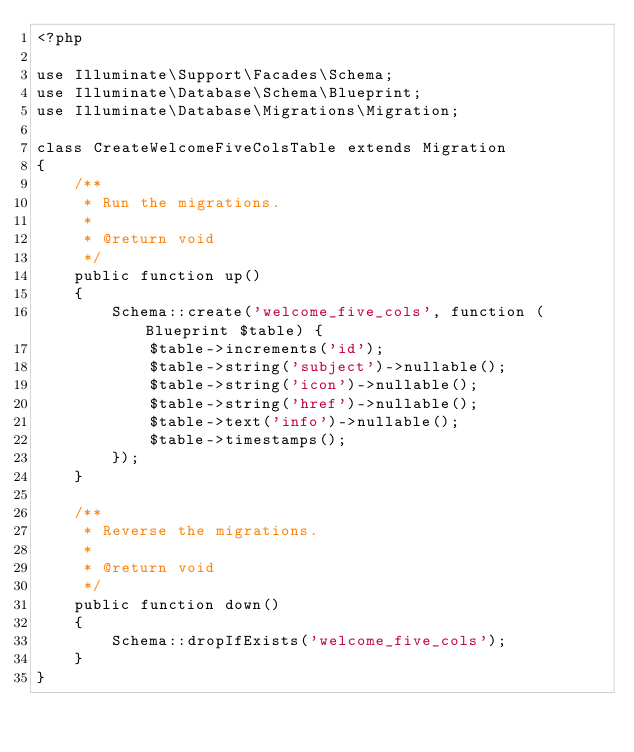<code> <loc_0><loc_0><loc_500><loc_500><_PHP_><?php

use Illuminate\Support\Facades\Schema;
use Illuminate\Database\Schema\Blueprint;
use Illuminate\Database\Migrations\Migration;

class CreateWelcomeFiveColsTable extends Migration
{
    /**
     * Run the migrations.
     *
     * @return void
     */
    public function up()
    {
        Schema::create('welcome_five_cols', function (Blueprint $table) {
            $table->increments('id');
            $table->string('subject')->nullable();
            $table->string('icon')->nullable();
            $table->string('href')->nullable();
            $table->text('info')->nullable();
            $table->timestamps();
        });
    }

    /**
     * Reverse the migrations.
     *
     * @return void
     */
    public function down()
    {
        Schema::dropIfExists('welcome_five_cols');
    }
}
</code> 